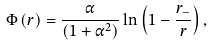<formula> <loc_0><loc_0><loc_500><loc_500>\Phi \left ( r \right ) = \frac { \alpha } { \left ( 1 + { \alpha } ^ { 2 } \right ) } \ln \left ( 1 - { \frac { r _ { - } } { r } } \right ) ,</formula> 